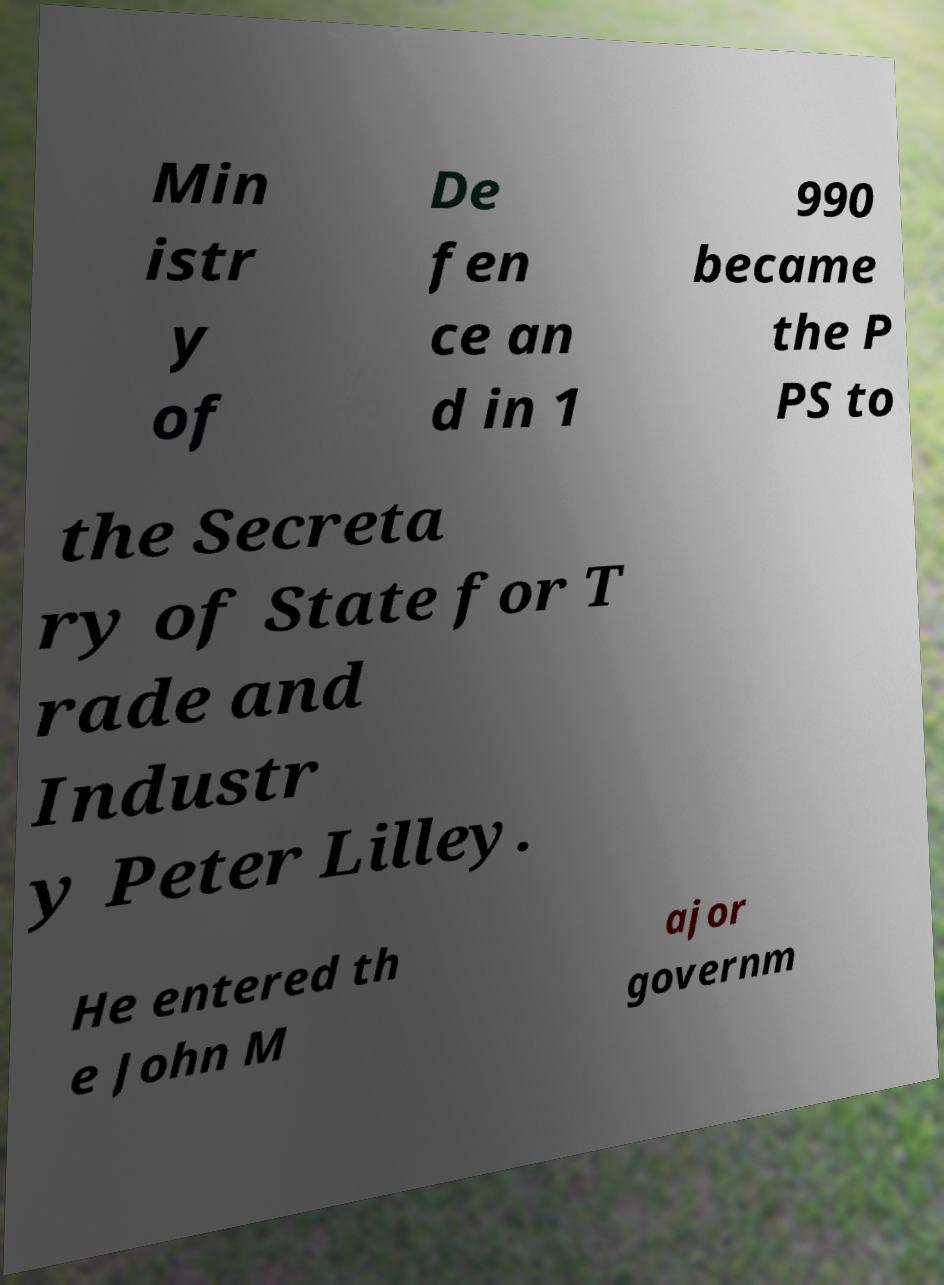Can you read and provide the text displayed in the image?This photo seems to have some interesting text. Can you extract and type it out for me? Min istr y of De fen ce an d in 1 990 became the P PS to the Secreta ry of State for T rade and Industr y Peter Lilley. He entered th e John M ajor governm 